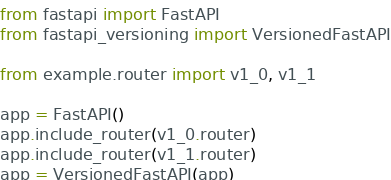Convert code to text. <code><loc_0><loc_0><loc_500><loc_500><_Python_>from fastapi import FastAPI
from fastapi_versioning import VersionedFastAPI

from example.router import v1_0, v1_1

app = FastAPI()
app.include_router(v1_0.router)
app.include_router(v1_1.router)
app = VersionedFastAPI(app)
</code> 